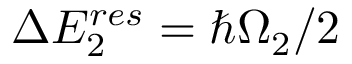Convert formula to latex. <formula><loc_0><loc_0><loc_500><loc_500>\Delta E _ { 2 } ^ { r e s } = \hbar { \Omega } _ { 2 } / 2</formula> 